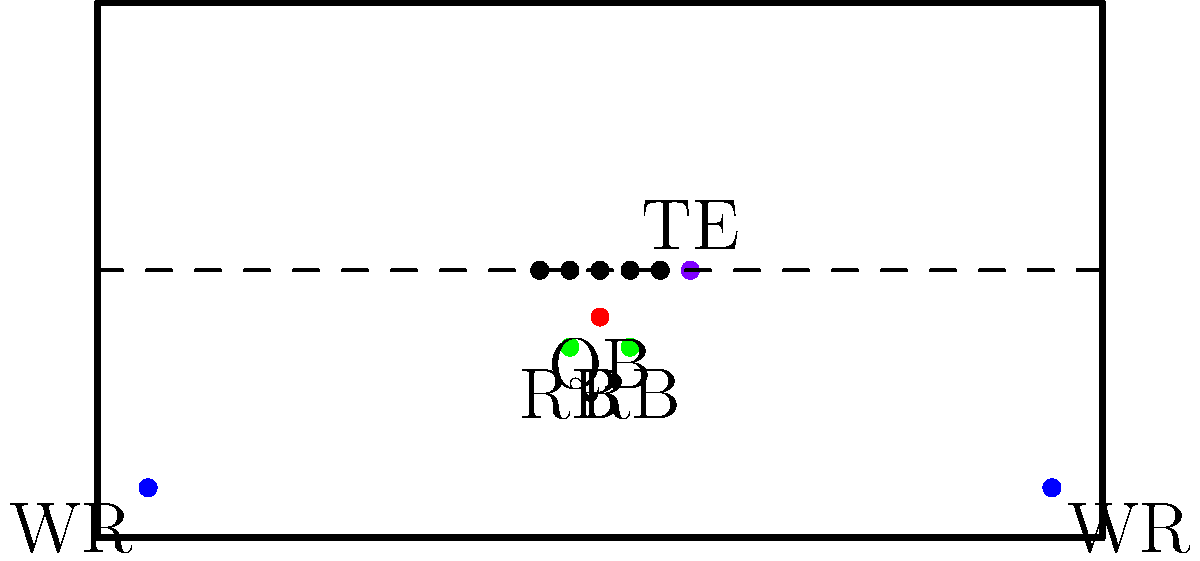Analyze the offensive formation shown in the diagram. How might this formation create challenges for the defense, and what potential passing routes could be effectively utilized, particularly considering the positioning of the tight end? To analyze this offensive formation and its potential challenges for the defense, let's break it down step-by-step:

1. Formation Identification: This is a "Shotgun" formation with "21" personnel (2 RBs, 1 TE, 2 WRs).

2. Quarterback Position: The QB is in shotgun, providing better vision of the field and more time for plays to develop.

3. Running Back Positioning: Two RBs are positioned on either side of the QB, offering multiple options:
   a) Pass protection
   b) Outlet receivers
   c) Run threats

4. Wide Receiver Spread: The WRs are spread wide, stretching the defense horizontally.

5. Tight End Alignment: The TE is on the right side of the formation, creating an unbalanced line.

6. Defensive Challenges:
   a) The spread formation forces the defense to cover more ground.
   b) The presence of two RBs and a TE creates uncertainty about run vs. pass.
   c) The unbalanced line may require defensive adjustments.

7. Potential Passing Routes:
   a) TE seam route: Exploits the space between linebackers and safeties.
   b) RB wheel routes: Can create mismatches against linebackers.
   c) WR deep routes: Spread formation allows for vertical threats.
   d) TE crossing routes: Can take advantage of defensive focus on WRs and RBs.

8. TE Importance:
   a) Can stay in to block, creating a 7-man protection scheme.
   b) Can release into routes, potentially surprising the defense.
   c) Creates a mismatch against smaller DBs or slower LBs.

This formation's versatility and the TE's positioning allow for multiple play options, making it challenging for the defense to predict and counter effectively.
Answer: Spread formation with TE creates defensive mismatches and diverse route options, particularly exploiting seam and crossing routes for the TE. 